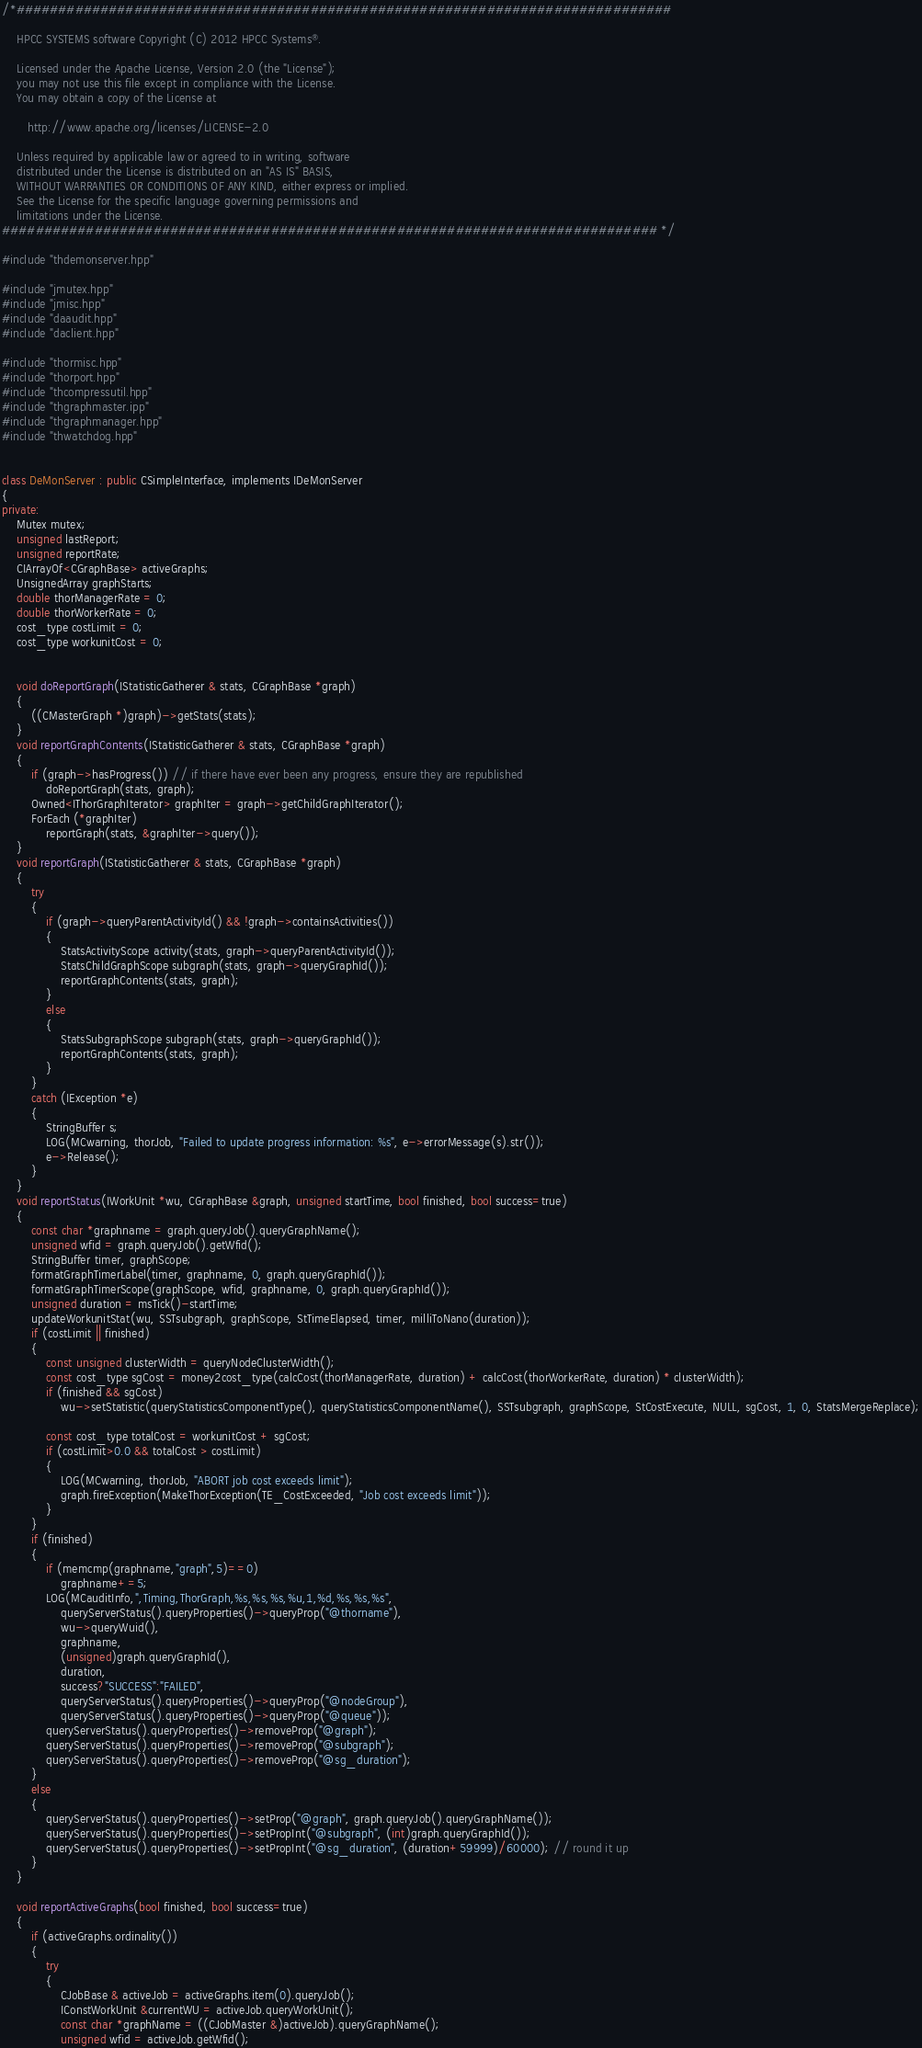<code> <loc_0><loc_0><loc_500><loc_500><_C++_>/*##############################################################################

    HPCC SYSTEMS software Copyright (C) 2012 HPCC Systems®.

    Licensed under the Apache License, Version 2.0 (the "License");
    you may not use this file except in compliance with the License.
    You may obtain a copy of the License at

       http://www.apache.org/licenses/LICENSE-2.0

    Unless required by applicable law or agreed to in writing, software
    distributed under the License is distributed on an "AS IS" BASIS,
    WITHOUT WARRANTIES OR CONDITIONS OF ANY KIND, either express or implied.
    See the License for the specific language governing permissions and
    limitations under the License.
############################################################################## */

#include "thdemonserver.hpp"

#include "jmutex.hpp"
#include "jmisc.hpp"
#include "daaudit.hpp"
#include "daclient.hpp"

#include "thormisc.hpp"
#include "thorport.hpp"
#include "thcompressutil.hpp"
#include "thgraphmaster.ipp"
#include "thgraphmanager.hpp"
#include "thwatchdog.hpp"


class DeMonServer : public CSimpleInterface, implements IDeMonServer
{
private:
    Mutex mutex;
    unsigned lastReport;
    unsigned reportRate;
    CIArrayOf<CGraphBase> activeGraphs;
    UnsignedArray graphStarts;
    double thorManagerRate = 0;
    double thorWorkerRate = 0;
    cost_type costLimit = 0;
    cost_type workunitCost = 0;

    
    void doReportGraph(IStatisticGatherer & stats, CGraphBase *graph)
    {
        ((CMasterGraph *)graph)->getStats(stats);
    }
    void reportGraphContents(IStatisticGatherer & stats, CGraphBase *graph)
    {
        if (graph->hasProgress()) // if there have ever been any progress, ensure they are republished
            doReportGraph(stats, graph);
        Owned<IThorGraphIterator> graphIter = graph->getChildGraphIterator();
        ForEach (*graphIter)
            reportGraph(stats, &graphIter->query());
    }
    void reportGraph(IStatisticGatherer & stats, CGraphBase *graph)
    {
        try
        {
            if (graph->queryParentActivityId() && !graph->containsActivities())
            {
                StatsActivityScope activity(stats, graph->queryParentActivityId());
                StatsChildGraphScope subgraph(stats, graph->queryGraphId());
                reportGraphContents(stats, graph);
            }
            else
            {
                StatsSubgraphScope subgraph(stats, graph->queryGraphId());
                reportGraphContents(stats, graph);
            }
        }
        catch (IException *e)
        {
            StringBuffer s;
            LOG(MCwarning, thorJob, "Failed to update progress information: %s", e->errorMessage(s).str());
            e->Release();
        }
    }
    void reportStatus(IWorkUnit *wu, CGraphBase &graph, unsigned startTime, bool finished, bool success=true)
    {
        const char *graphname = graph.queryJob().queryGraphName();
        unsigned wfid = graph.queryJob().getWfid();
        StringBuffer timer, graphScope;
        formatGraphTimerLabel(timer, graphname, 0, graph.queryGraphId());
        formatGraphTimerScope(graphScope, wfid, graphname, 0, graph.queryGraphId());
        unsigned duration = msTick()-startTime;
        updateWorkunitStat(wu, SSTsubgraph, graphScope, StTimeElapsed, timer, milliToNano(duration));
        if (costLimit || finished)
        {
            const unsigned clusterWidth = queryNodeClusterWidth();
            const cost_type sgCost = money2cost_type(calcCost(thorManagerRate, duration) + calcCost(thorWorkerRate, duration) * clusterWidth);
            if (finished && sgCost)
                wu->setStatistic(queryStatisticsComponentType(), queryStatisticsComponentName(), SSTsubgraph, graphScope, StCostExecute, NULL, sgCost, 1, 0, StatsMergeReplace);

            const cost_type totalCost = workunitCost + sgCost;
            if (costLimit>0.0 && totalCost > costLimit)
            {
                LOG(MCwarning, thorJob, "ABORT job cost exceeds limit");
                graph.fireException(MakeThorException(TE_CostExceeded, "Job cost exceeds limit"));
            }
        }
        if (finished)
        {
            if (memcmp(graphname,"graph",5)==0)
                graphname+=5;
            LOG(MCauditInfo,",Timing,ThorGraph,%s,%s,%s,%u,1,%d,%s,%s,%s",
                queryServerStatus().queryProperties()->queryProp("@thorname"),
                wu->queryWuid(),
                graphname,
                (unsigned)graph.queryGraphId(),
                duration,
                success?"SUCCESS":"FAILED",
                queryServerStatus().queryProperties()->queryProp("@nodeGroup"),
                queryServerStatus().queryProperties()->queryProp("@queue"));
            queryServerStatus().queryProperties()->removeProp("@graph");
            queryServerStatus().queryProperties()->removeProp("@subgraph");
            queryServerStatus().queryProperties()->removeProp("@sg_duration");
        }
        else
        {
            queryServerStatus().queryProperties()->setProp("@graph", graph.queryJob().queryGraphName());
            queryServerStatus().queryProperties()->setPropInt("@subgraph", (int)graph.queryGraphId());
            queryServerStatus().queryProperties()->setPropInt("@sg_duration", (duration+59999)/60000); // round it up
        }
    }

    void reportActiveGraphs(bool finished, bool success=true)
    {
        if (activeGraphs.ordinality())
        {
            try
            {
                CJobBase & activeJob = activeGraphs.item(0).queryJob();
                IConstWorkUnit &currentWU = activeJob.queryWorkUnit();
                const char *graphName = ((CJobMaster &)activeJob).queryGraphName();
                unsigned wfid = activeJob.getWfid();</code> 